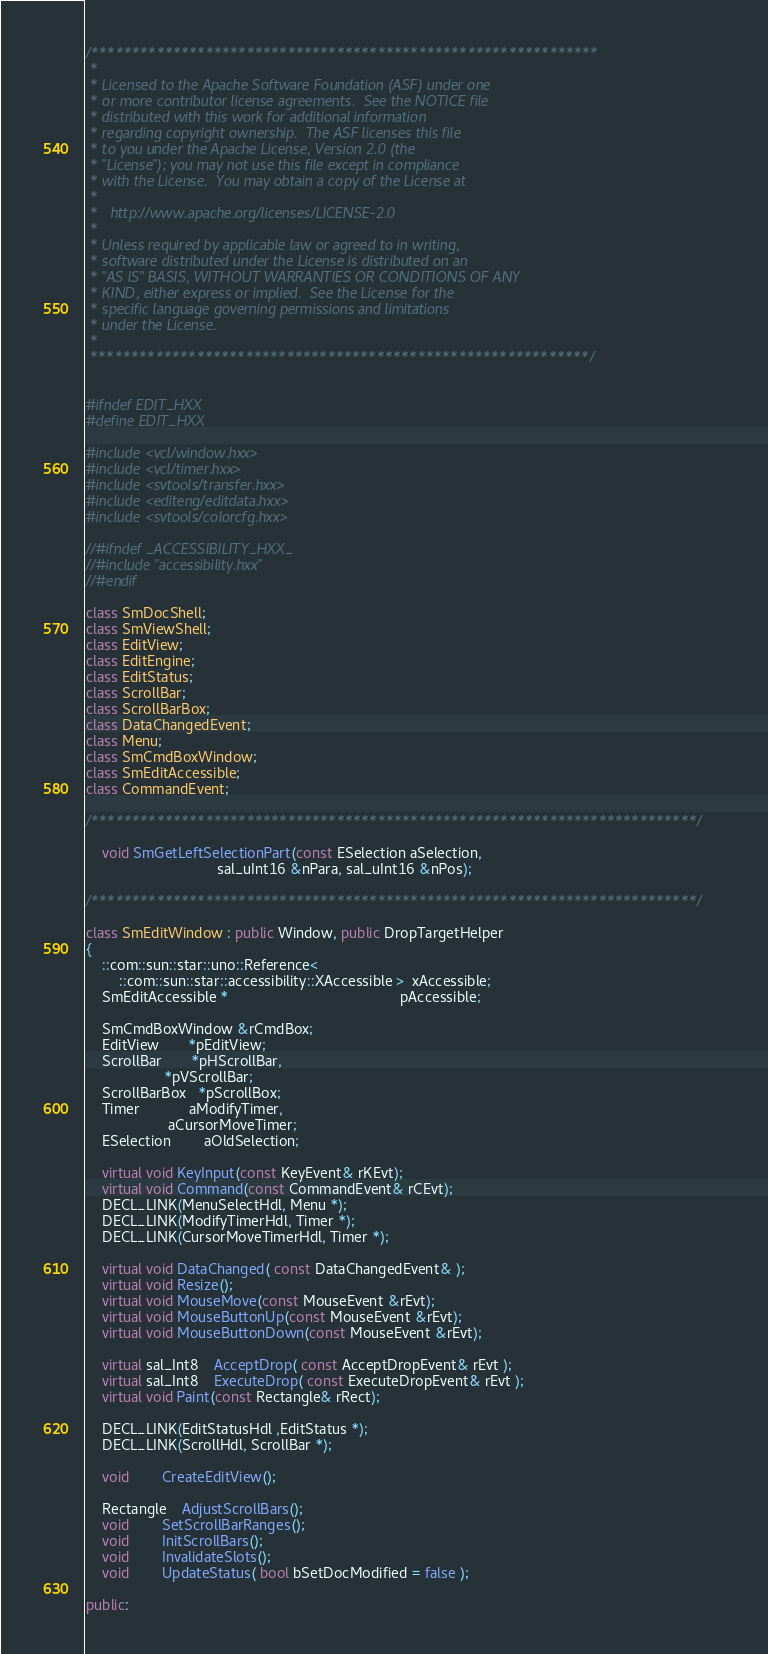Convert code to text. <code><loc_0><loc_0><loc_500><loc_500><_C++_>/**************************************************************
 * 
 * Licensed to the Apache Software Foundation (ASF) under one
 * or more contributor license agreements.  See the NOTICE file
 * distributed with this work for additional information
 * regarding copyright ownership.  The ASF licenses this file
 * to you under the Apache License, Version 2.0 (the
 * "License"); you may not use this file except in compliance
 * with the License.  You may obtain a copy of the License at
 * 
 *   http://www.apache.org/licenses/LICENSE-2.0
 * 
 * Unless required by applicable law or agreed to in writing,
 * software distributed under the License is distributed on an
 * "AS IS" BASIS, WITHOUT WARRANTIES OR CONDITIONS OF ANY
 * KIND, either express or implied.  See the License for the
 * specific language governing permissions and limitations
 * under the License.
 * 
 *************************************************************/


#ifndef EDIT_HXX
#define EDIT_HXX

#include <vcl/window.hxx>
#include <vcl/timer.hxx>
#include <svtools/transfer.hxx>
#include <editeng/editdata.hxx>
#include <svtools/colorcfg.hxx>

//#ifndef _ACCESSIBILITY_HXX_
//#include "accessibility.hxx"
//#endif

class SmDocShell;
class SmViewShell;
class EditView;
class EditEngine;
class EditStatus;
class ScrollBar;
class ScrollBarBox;
class DataChangedEvent;
class Menu;
class SmCmdBoxWindow;
class SmEditAccessible;
class CommandEvent;

/**************************************************************************/

	void SmGetLeftSelectionPart(const ESelection aSelection,
								sal_uInt16 &nPara, sal_uInt16 &nPos);

/**************************************************************************/

class SmEditWindow : public Window, public DropTargetHelper
{
    ::com::sun::star::uno::Reference<
        ::com::sun::star::accessibility::XAccessible >  xAccessible;
    SmEditAccessible *                                          pAccessible;

    SmCmdBoxWindow &rCmdBox;
	EditView	   *pEditView;
	ScrollBar	   *pHScrollBar,
				   *pVScrollBar;
	ScrollBarBox   *pScrollBox;
	Timer			aModifyTimer,
					aCursorMoveTimer;
	ESelection		aOldSelection;

	virtual void KeyInput(const KeyEvent& rKEvt);
	virtual void Command(const CommandEvent& rCEvt);
	DECL_LINK(MenuSelectHdl, Menu *);
	DECL_LINK(ModifyTimerHdl, Timer *);
	DECL_LINK(CursorMoveTimerHdl, Timer *);

	virtual void DataChanged( const DataChangedEvent& );
	virtual void Resize();
	virtual void MouseMove(const MouseEvent &rEvt);
	virtual void MouseButtonUp(const MouseEvent &rEvt);
	virtual void MouseButtonDown(const MouseEvent &rEvt);

    virtual sal_Int8    AcceptDrop( const AcceptDropEvent& rEvt );
    virtual sal_Int8    ExecuteDrop( const ExecuteDropEvent& rEvt );
	virtual void Paint(const Rectangle& rRect);

	DECL_LINK(EditStatusHdl ,EditStatus *);
	DECL_LINK(ScrollHdl, ScrollBar *);

	void 		CreateEditView();

	Rectangle 	AdjustScrollBars();
	void 		SetScrollBarRanges();
	void 		InitScrollBars();
	void		InvalidateSlots();
    void        UpdateStatus( bool bSetDocModified = false );

public:</code> 